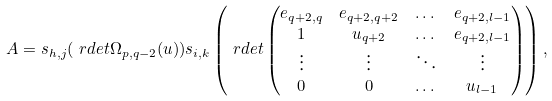<formula> <loc_0><loc_0><loc_500><loc_500>A & = s _ { h , j } ( \ r d e t \Omega _ { p , q - 2 } ( u ) ) s _ { i , k } \left ( \ r d e t \begin{pmatrix} e _ { q + 2 , q } & e _ { q + 2 , q + 2 } & \dots & e _ { q + 2 , l - 1 } \\ 1 & u _ { q + 2 } & \dots & e _ { q + 2 , l - 1 } \\ \vdots & \vdots & \ddots & \vdots \\ 0 & 0 & \dots & u _ { l - 1 } \end{pmatrix} \right ) ,</formula> 